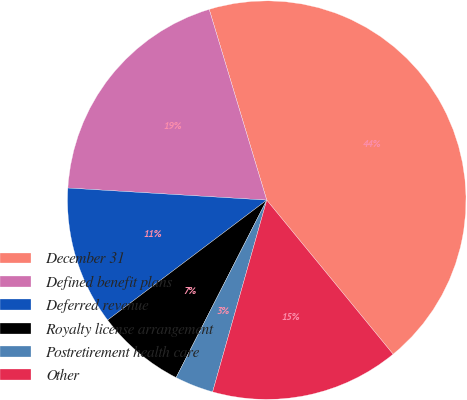Convert chart. <chart><loc_0><loc_0><loc_500><loc_500><pie_chart><fcel>December 31<fcel>Defined benefit plans<fcel>Deferred revenue<fcel>Royalty license arrangement<fcel>Postretirement health care<fcel>Other<nl><fcel>43.73%<fcel>19.37%<fcel>11.25%<fcel>7.2%<fcel>3.14%<fcel>15.31%<nl></chart> 